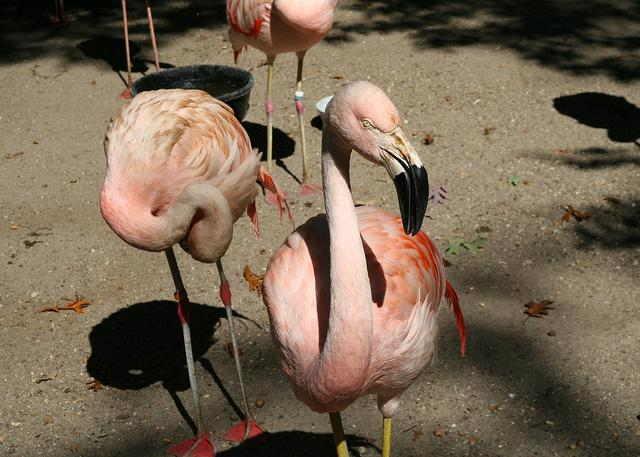What aquatic order are these birds from?

Choices:
A) phoenicopteriformes
B) vegaviiformes
C) podicipediformes
D) anseriformes phoenicopteriformes 